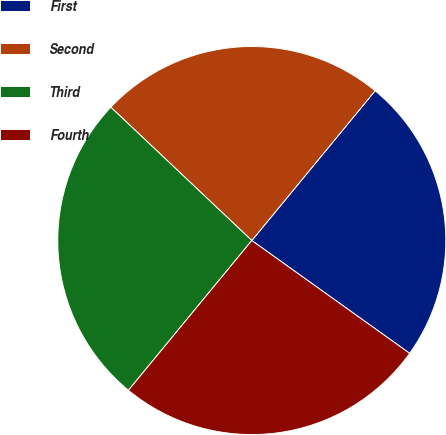<chart> <loc_0><loc_0><loc_500><loc_500><pie_chart><fcel>First<fcel>Second<fcel>Third<fcel>Fourth<nl><fcel>23.91%<fcel>23.91%<fcel>26.09%<fcel>26.09%<nl></chart> 